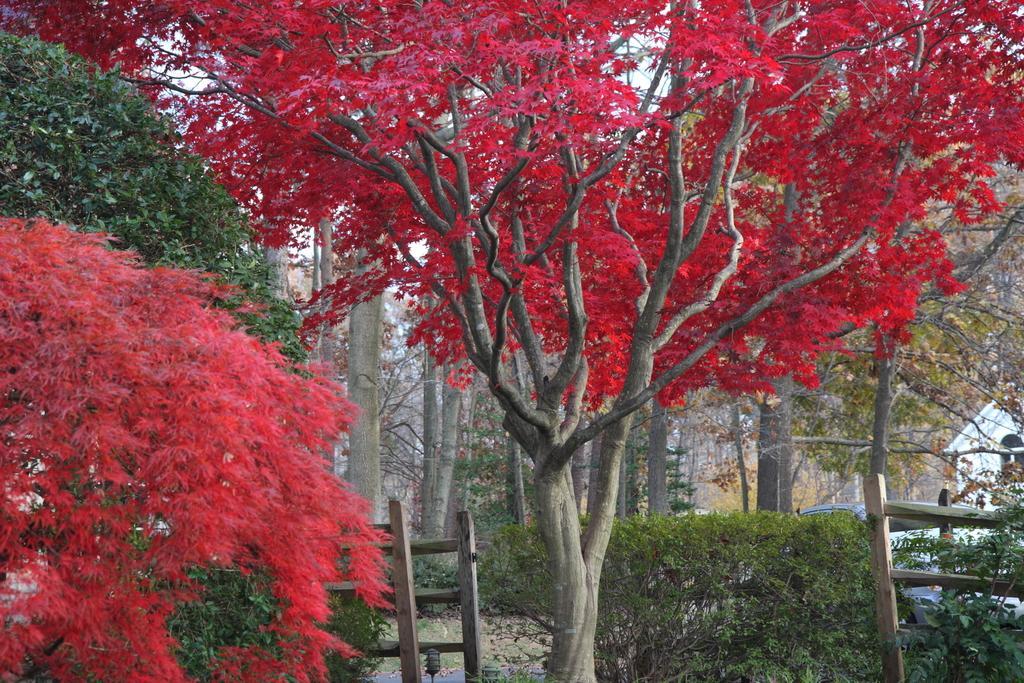Could you give a brief overview of what you see in this image? In this image, we can see the trees and there is a sky in the background. 